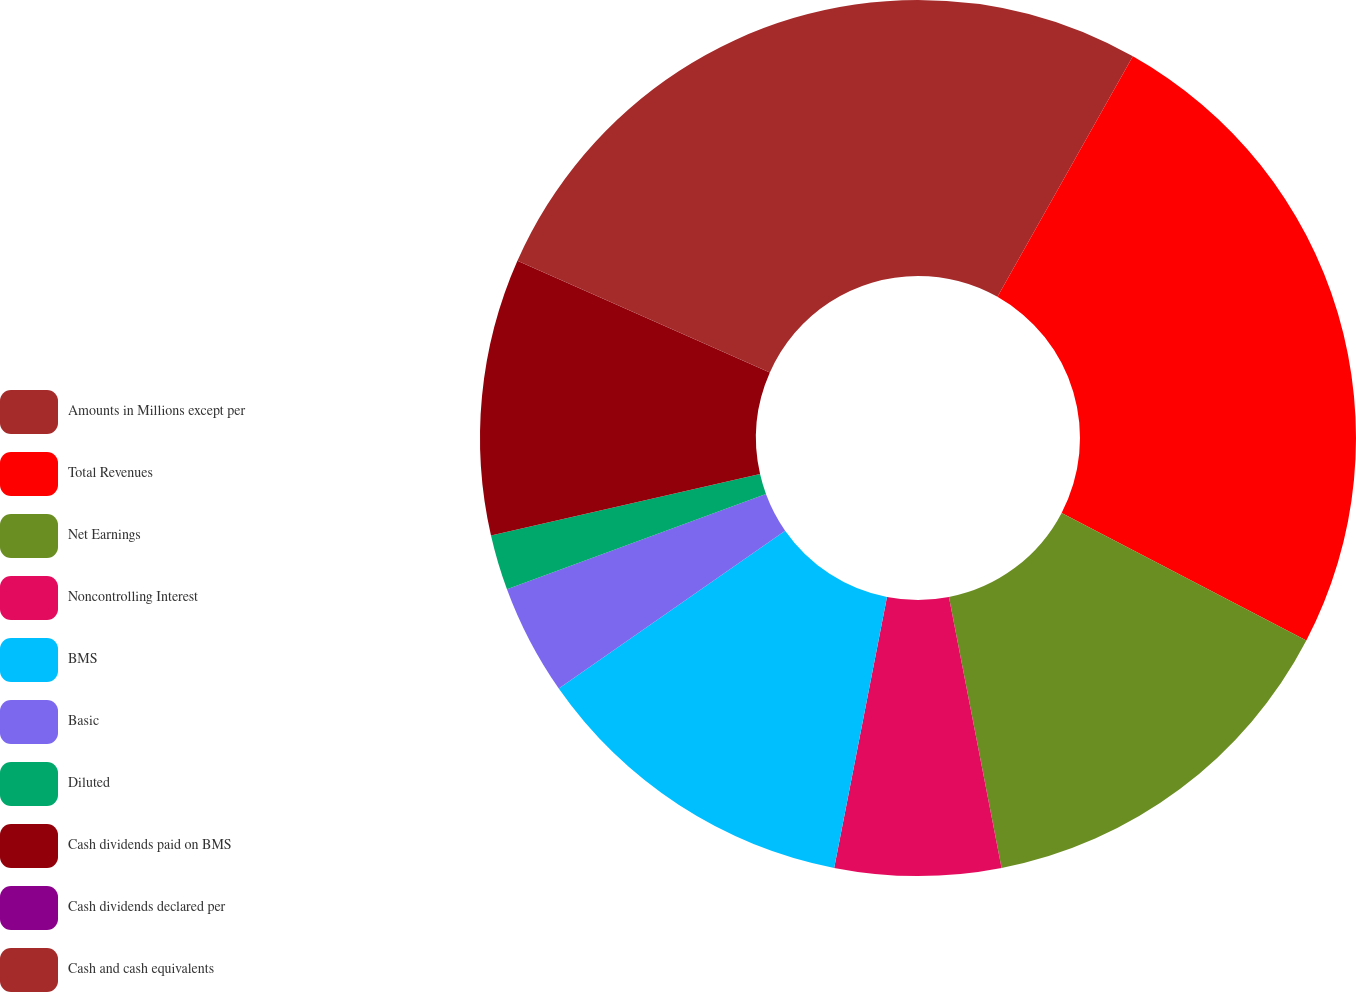<chart> <loc_0><loc_0><loc_500><loc_500><pie_chart><fcel>Amounts in Millions except per<fcel>Total Revenues<fcel>Net Earnings<fcel>Noncontrolling Interest<fcel>BMS<fcel>Basic<fcel>Diluted<fcel>Cash dividends paid on BMS<fcel>Cash dividends declared per<fcel>Cash and cash equivalents<nl><fcel>8.16%<fcel>24.49%<fcel>14.29%<fcel>6.12%<fcel>12.24%<fcel>4.08%<fcel>2.04%<fcel>10.2%<fcel>0.0%<fcel>18.37%<nl></chart> 